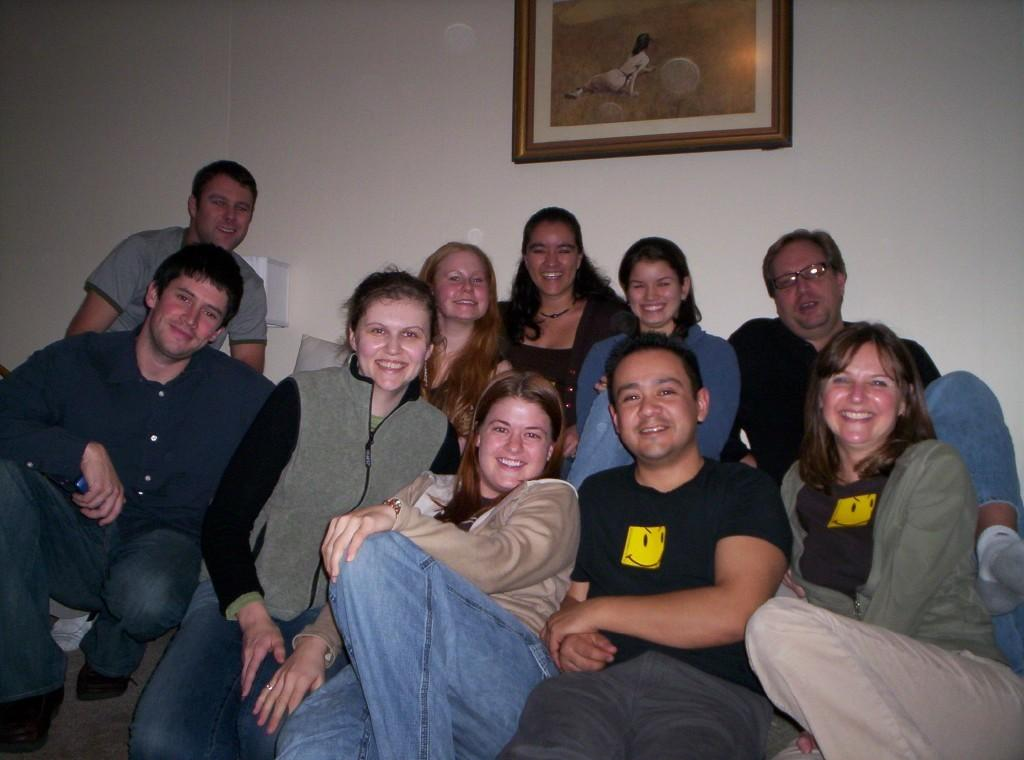How many people are in the image? There is a group of people in the image, but the exact number cannot be determined from the provided facts. What can be seen on the wall in the background of the image? There is a photo frame on the wall in the background of the image. How many bees are buzzing around the people in the image? There is no mention of bees in the image, so we cannot determine the number of bees present. 